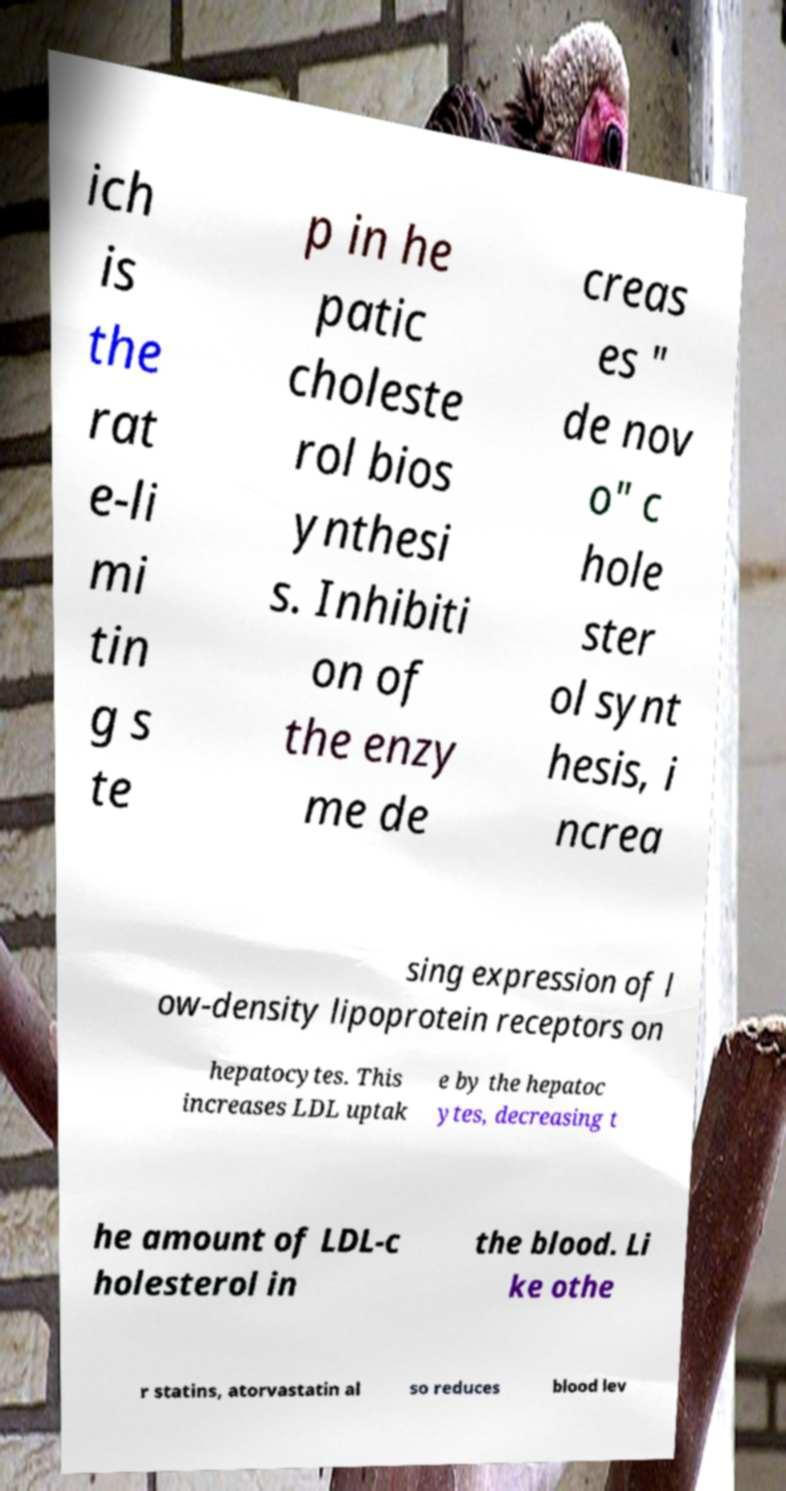Can you accurately transcribe the text from the provided image for me? ich is the rat e-li mi tin g s te p in he patic choleste rol bios ynthesi s. Inhibiti on of the enzy me de creas es " de nov o" c hole ster ol synt hesis, i ncrea sing expression of l ow-density lipoprotein receptors on hepatocytes. This increases LDL uptak e by the hepatoc ytes, decreasing t he amount of LDL-c holesterol in the blood. Li ke othe r statins, atorvastatin al so reduces blood lev 